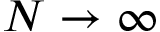Convert formula to latex. <formula><loc_0><loc_0><loc_500><loc_500>N \rightarrow \infty</formula> 